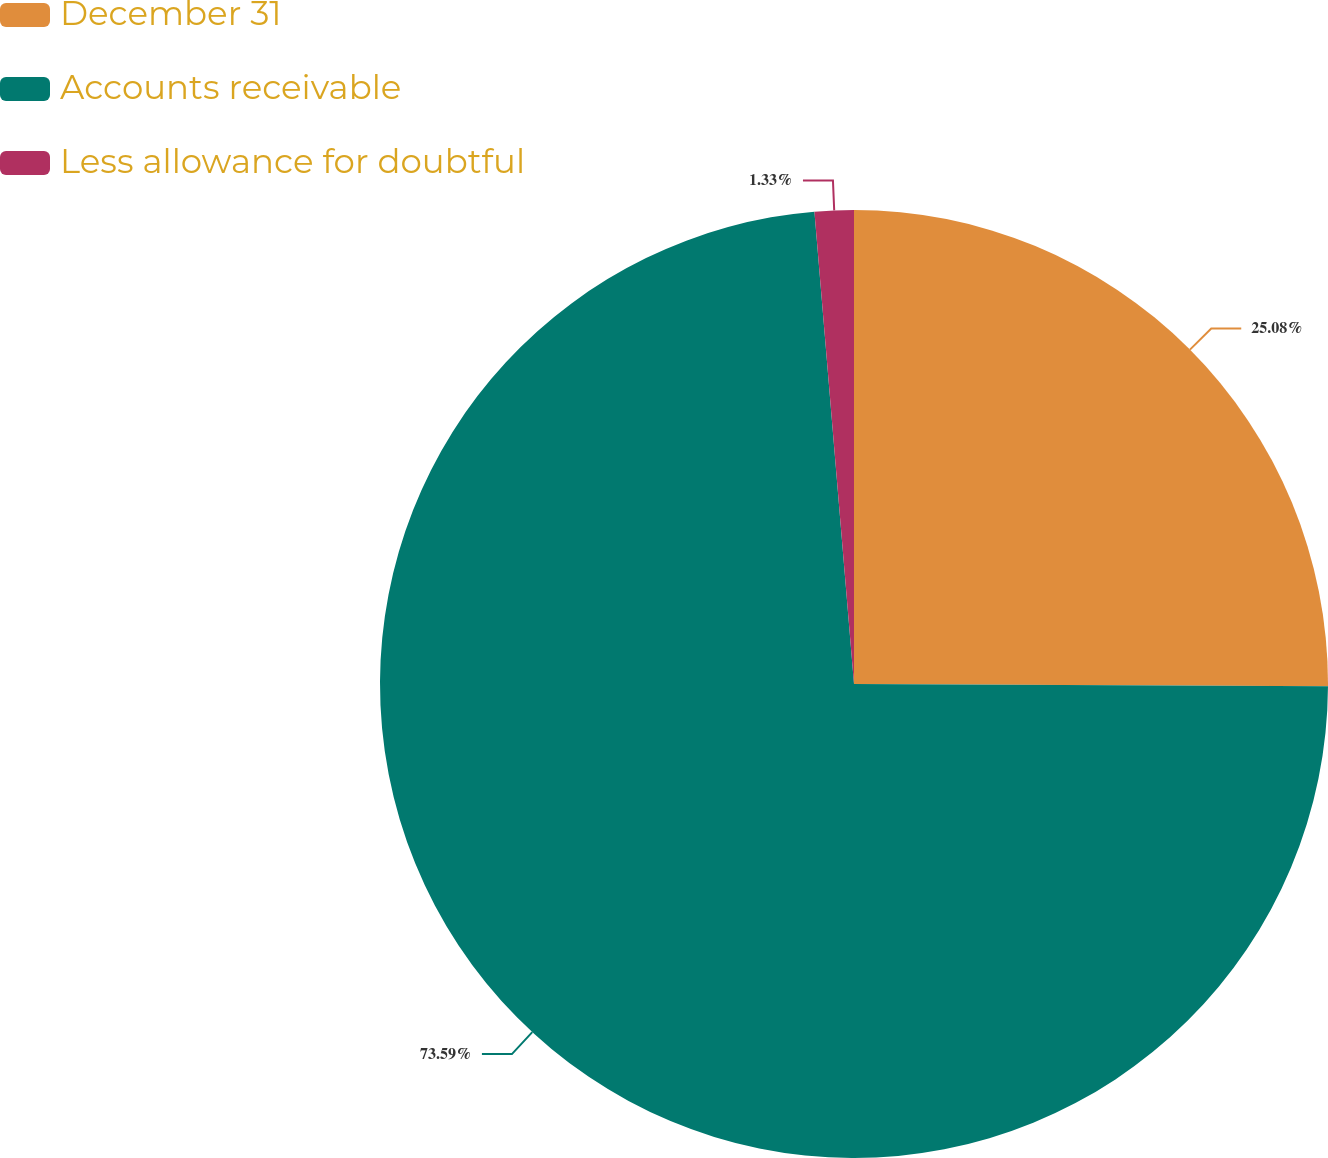Convert chart to OTSL. <chart><loc_0><loc_0><loc_500><loc_500><pie_chart><fcel>December 31<fcel>Accounts receivable<fcel>Less allowance for doubtful<nl><fcel>25.08%<fcel>73.6%<fcel>1.33%<nl></chart> 